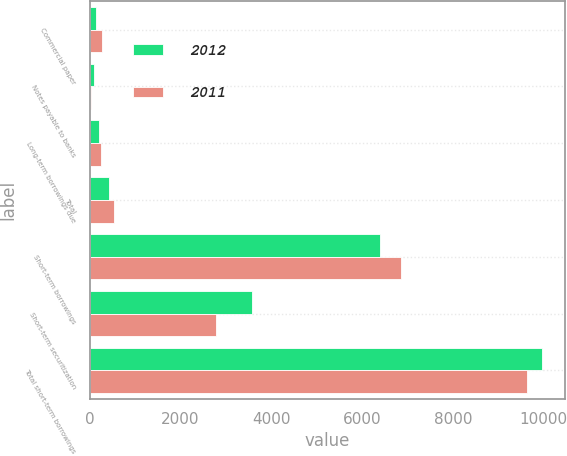<chart> <loc_0><loc_0><loc_500><loc_500><stacked_bar_chart><ecel><fcel>Commercial paper<fcel>Notes payable to banks<fcel>Long-term borrowings due<fcel>Total<fcel>Short-term borrowings<fcel>Short-term securitization<fcel>Total short-term borrowings<nl><fcel>2012<fcel>146<fcel>84<fcel>195<fcel>425<fcel>6393<fcel>3575<fcel>9968<nl><fcel>2011<fcel>265<fcel>19<fcel>244<fcel>528<fcel>6852<fcel>2777<fcel>9629<nl></chart> 